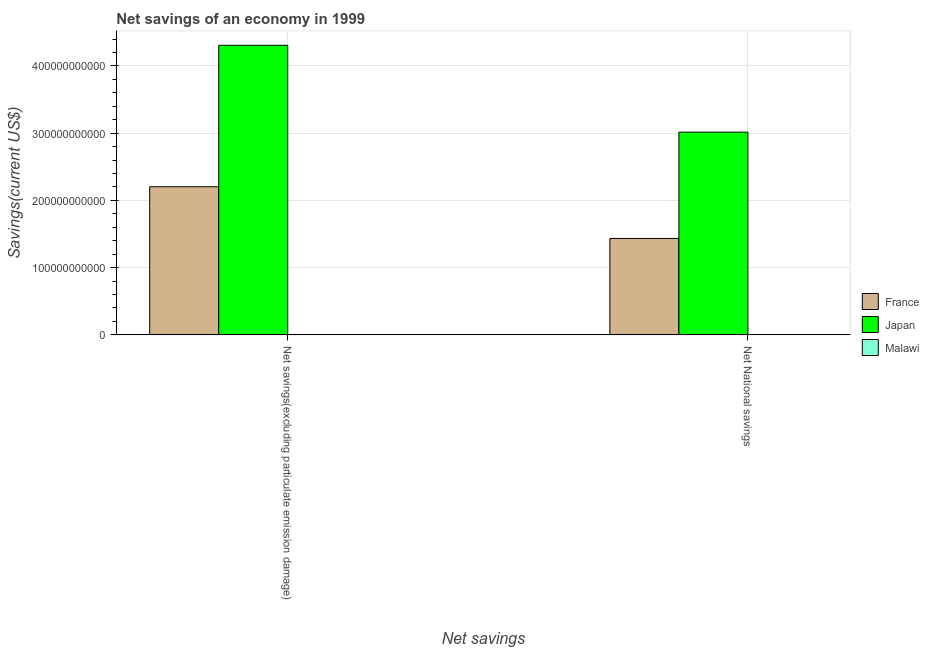How many different coloured bars are there?
Give a very brief answer. 2. How many groups of bars are there?
Make the answer very short. 2. Are the number of bars per tick equal to the number of legend labels?
Your answer should be compact. No. How many bars are there on the 1st tick from the left?
Keep it short and to the point. 2. How many bars are there on the 1st tick from the right?
Offer a very short reply. 2. What is the label of the 1st group of bars from the left?
Your answer should be compact. Net savings(excluding particulate emission damage). What is the net savings(excluding particulate emission damage) in Malawi?
Give a very brief answer. 0. Across all countries, what is the maximum net savings(excluding particulate emission damage)?
Your answer should be compact. 4.31e+11. Across all countries, what is the minimum net savings(excluding particulate emission damage)?
Give a very brief answer. 0. In which country was the net national savings maximum?
Make the answer very short. Japan. What is the total net national savings in the graph?
Make the answer very short. 4.45e+11. What is the difference between the net national savings in France and that in Japan?
Offer a very short reply. -1.58e+11. What is the difference between the net savings(excluding particulate emission damage) in Japan and the net national savings in Malawi?
Offer a terse response. 4.31e+11. What is the average net national savings per country?
Make the answer very short. 1.48e+11. What is the difference between the net savings(excluding particulate emission damage) and net national savings in France?
Your answer should be compact. 7.70e+1. In how many countries, is the net national savings greater than 160000000000 US$?
Ensure brevity in your answer.  1. What is the ratio of the net savings(excluding particulate emission damage) in France to that in Japan?
Ensure brevity in your answer.  0.51. Is the net savings(excluding particulate emission damage) in Japan less than that in France?
Your answer should be compact. No. How many bars are there?
Offer a terse response. 4. Are all the bars in the graph horizontal?
Provide a succinct answer. No. What is the difference between two consecutive major ticks on the Y-axis?
Your answer should be compact. 1.00e+11. Are the values on the major ticks of Y-axis written in scientific E-notation?
Offer a terse response. No. Does the graph contain any zero values?
Give a very brief answer. Yes. Where does the legend appear in the graph?
Provide a short and direct response. Center right. How are the legend labels stacked?
Provide a short and direct response. Vertical. What is the title of the graph?
Offer a terse response. Net savings of an economy in 1999. Does "Papua New Guinea" appear as one of the legend labels in the graph?
Your answer should be very brief. No. What is the label or title of the X-axis?
Provide a succinct answer. Net savings. What is the label or title of the Y-axis?
Give a very brief answer. Savings(current US$). What is the Savings(current US$) of France in Net savings(excluding particulate emission damage)?
Your response must be concise. 2.20e+11. What is the Savings(current US$) of Japan in Net savings(excluding particulate emission damage)?
Ensure brevity in your answer.  4.31e+11. What is the Savings(current US$) in France in Net National savings?
Offer a terse response. 1.43e+11. What is the Savings(current US$) of Japan in Net National savings?
Provide a succinct answer. 3.02e+11. What is the Savings(current US$) in Malawi in Net National savings?
Offer a very short reply. 0. Across all Net savings, what is the maximum Savings(current US$) in France?
Keep it short and to the point. 2.20e+11. Across all Net savings, what is the maximum Savings(current US$) in Japan?
Offer a terse response. 4.31e+11. Across all Net savings, what is the minimum Savings(current US$) in France?
Provide a succinct answer. 1.43e+11. Across all Net savings, what is the minimum Savings(current US$) of Japan?
Provide a short and direct response. 3.02e+11. What is the total Savings(current US$) in France in the graph?
Offer a very short reply. 3.64e+11. What is the total Savings(current US$) of Japan in the graph?
Provide a short and direct response. 7.32e+11. What is the total Savings(current US$) in Malawi in the graph?
Give a very brief answer. 0. What is the difference between the Savings(current US$) of France in Net savings(excluding particulate emission damage) and that in Net National savings?
Ensure brevity in your answer.  7.70e+1. What is the difference between the Savings(current US$) in Japan in Net savings(excluding particulate emission damage) and that in Net National savings?
Ensure brevity in your answer.  1.29e+11. What is the difference between the Savings(current US$) of France in Net savings(excluding particulate emission damage) and the Savings(current US$) of Japan in Net National savings?
Provide a succinct answer. -8.12e+1. What is the average Savings(current US$) of France per Net savings?
Your answer should be compact. 1.82e+11. What is the average Savings(current US$) of Japan per Net savings?
Ensure brevity in your answer.  3.66e+11. What is the difference between the Savings(current US$) in France and Savings(current US$) in Japan in Net savings(excluding particulate emission damage)?
Ensure brevity in your answer.  -2.10e+11. What is the difference between the Savings(current US$) of France and Savings(current US$) of Japan in Net National savings?
Your answer should be compact. -1.58e+11. What is the ratio of the Savings(current US$) of France in Net savings(excluding particulate emission damage) to that in Net National savings?
Offer a terse response. 1.54. What is the ratio of the Savings(current US$) in Japan in Net savings(excluding particulate emission damage) to that in Net National savings?
Make the answer very short. 1.43. What is the difference between the highest and the second highest Savings(current US$) in France?
Provide a succinct answer. 7.70e+1. What is the difference between the highest and the second highest Savings(current US$) of Japan?
Make the answer very short. 1.29e+11. What is the difference between the highest and the lowest Savings(current US$) of France?
Offer a terse response. 7.70e+1. What is the difference between the highest and the lowest Savings(current US$) in Japan?
Make the answer very short. 1.29e+11. 